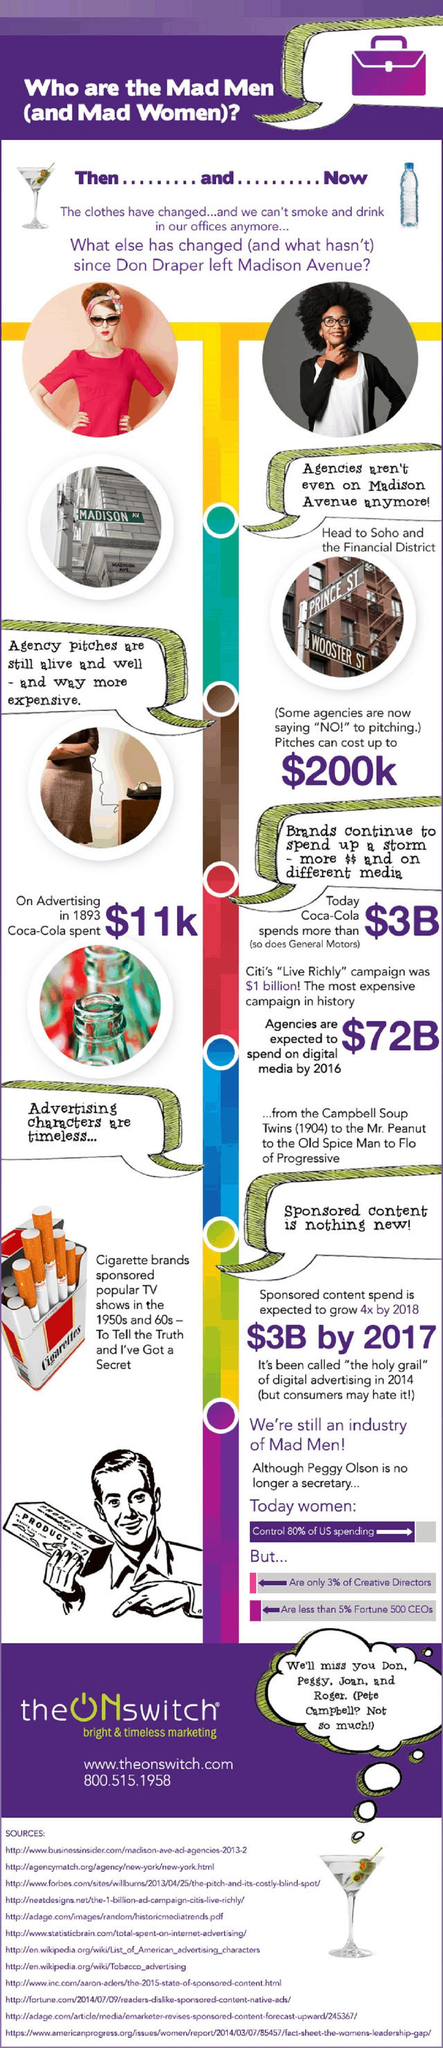Where is Prince and Wooster streets located?
Answer the question with a short phrase. Soho What is the amount spent by Coke on advertising, $11k, $3B, or $72B? $3B 